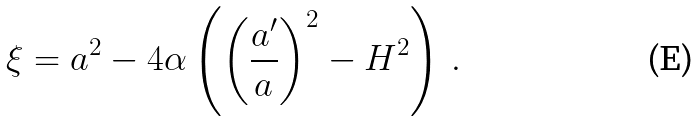<formula> <loc_0><loc_0><loc_500><loc_500>\xi = a ^ { 2 } - 4 \alpha \left ( \left ( \frac { a ^ { \prime } } { a } \right ) ^ { 2 } - H ^ { 2 } \right ) \, .</formula> 